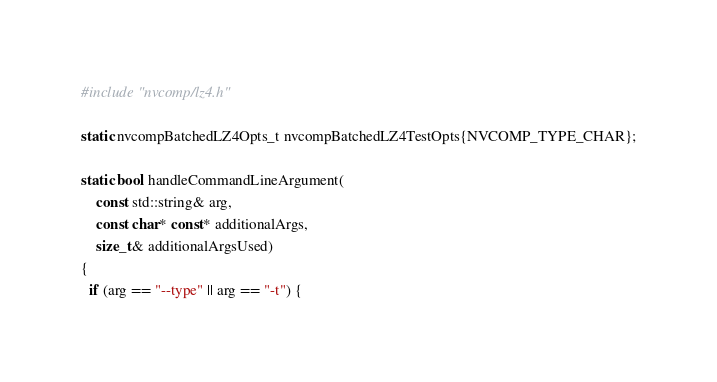Convert code to text. <code><loc_0><loc_0><loc_500><loc_500><_Cuda_>#include "nvcomp/lz4.h"

static nvcompBatchedLZ4Opts_t nvcompBatchedLZ4TestOpts{NVCOMP_TYPE_CHAR};

static bool handleCommandLineArgument(
    const std::string& arg,
    const char* const* additionalArgs,
    size_t& additionalArgsUsed)
{
  if (arg == "--type" || arg == "-t") {</code> 